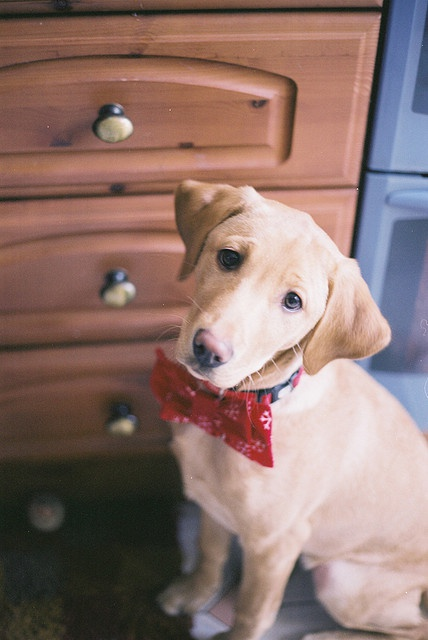Describe the objects in this image and their specific colors. I can see dog in black, lightgray, tan, gray, and darkgray tones and tie in black, maroon, brown, and lightpink tones in this image. 